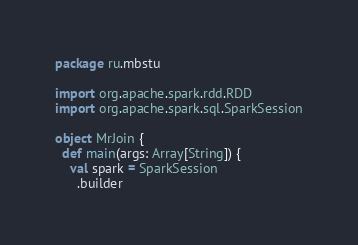<code> <loc_0><loc_0><loc_500><loc_500><_Scala_>package ru.mbstu

import org.apache.spark.rdd.RDD
import org.apache.spark.sql.SparkSession

object MrJoin {
  def main(args: Array[String]) {
    val spark = SparkSession
      .builder</code> 